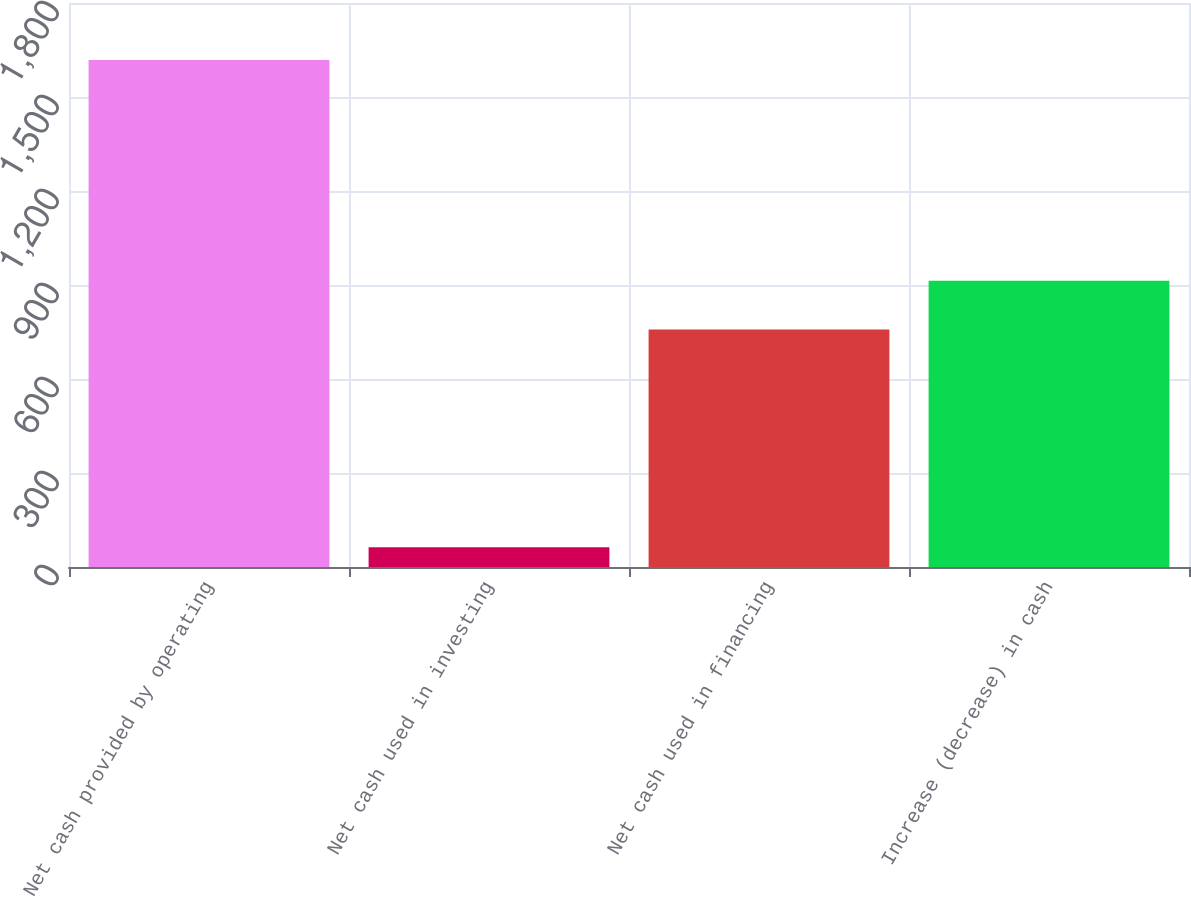Convert chart. <chart><loc_0><loc_0><loc_500><loc_500><bar_chart><fcel>Net cash provided by operating<fcel>Net cash used in investing<fcel>Net cash used in financing<fcel>Increase (decrease) in cash<nl><fcel>1618<fcel>63<fcel>758<fcel>913.5<nl></chart> 